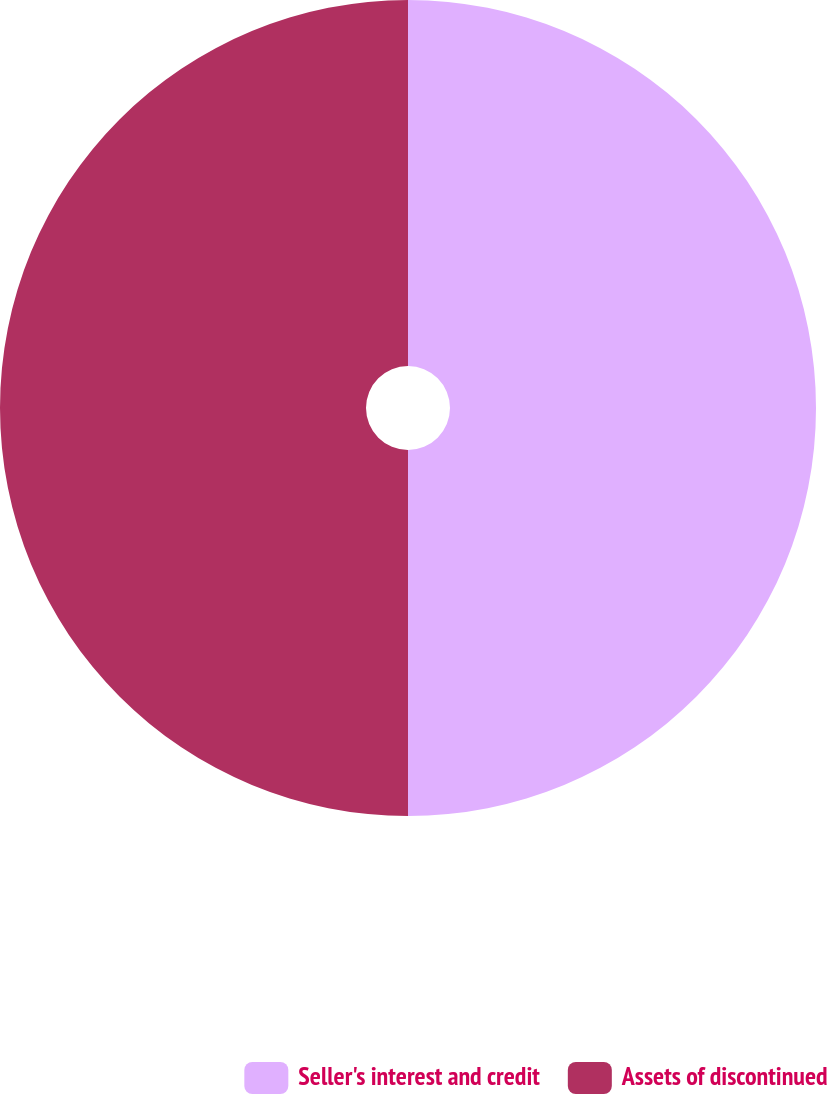<chart> <loc_0><loc_0><loc_500><loc_500><pie_chart><fcel>Seller's interest and credit<fcel>Assets of discontinued<nl><fcel>50.0%<fcel>50.0%<nl></chart> 